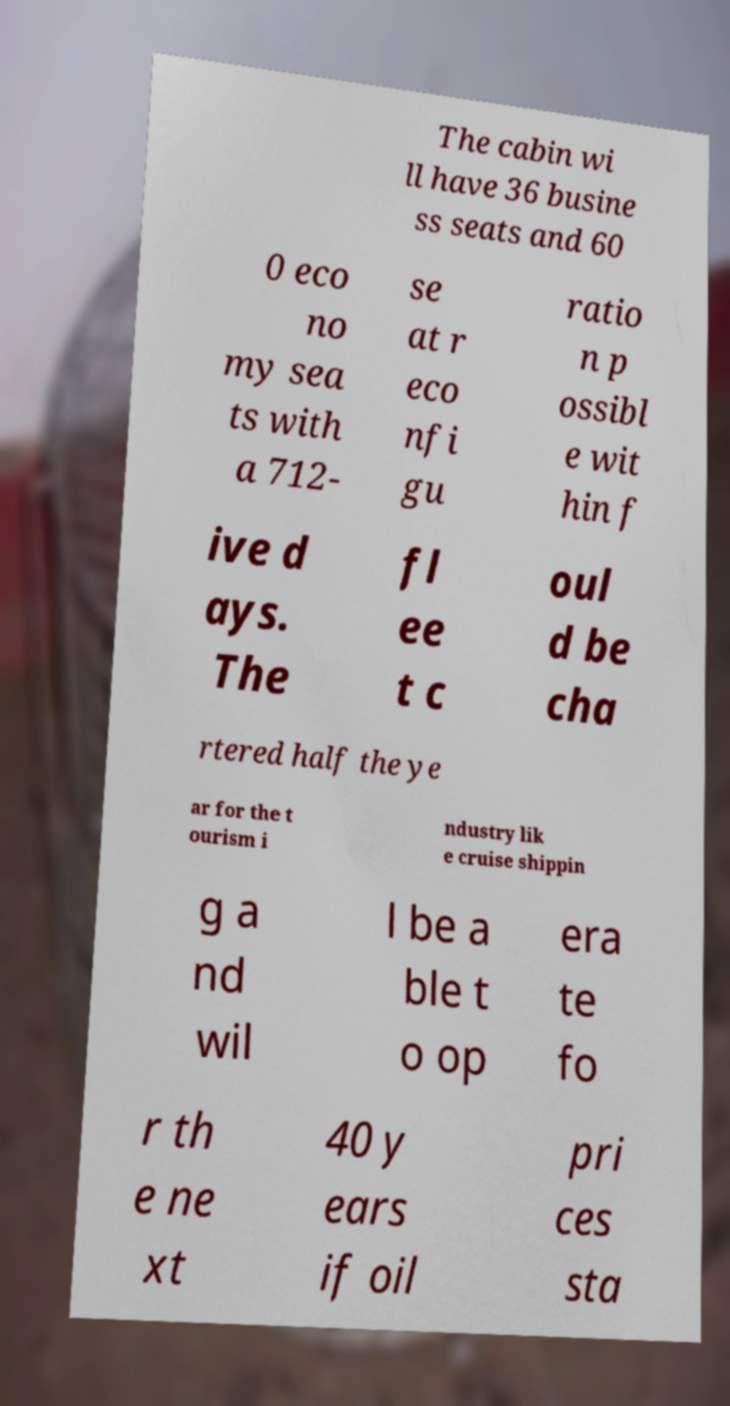There's text embedded in this image that I need extracted. Can you transcribe it verbatim? The cabin wi ll have 36 busine ss seats and 60 0 eco no my sea ts with a 712- se at r eco nfi gu ratio n p ossibl e wit hin f ive d ays. The fl ee t c oul d be cha rtered half the ye ar for the t ourism i ndustry lik e cruise shippin g a nd wil l be a ble t o op era te fo r th e ne xt 40 y ears if oil pri ces sta 